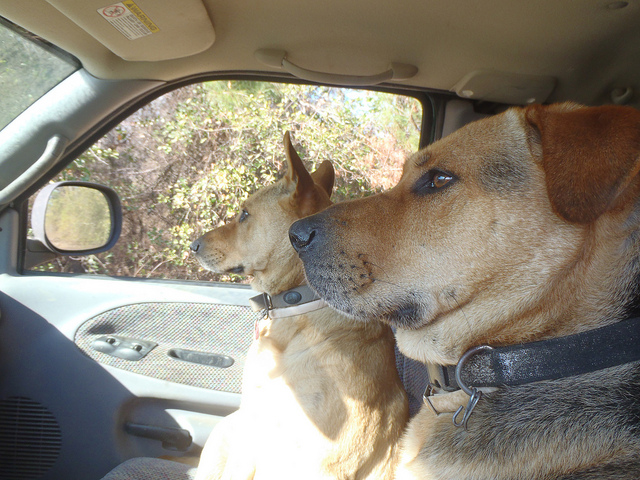What can you tell about the location from the image? Based on the foliage visible outside the car window and the sunlight filtering through, it seems like the location could be a rural or green area, likely during a sunny day. 